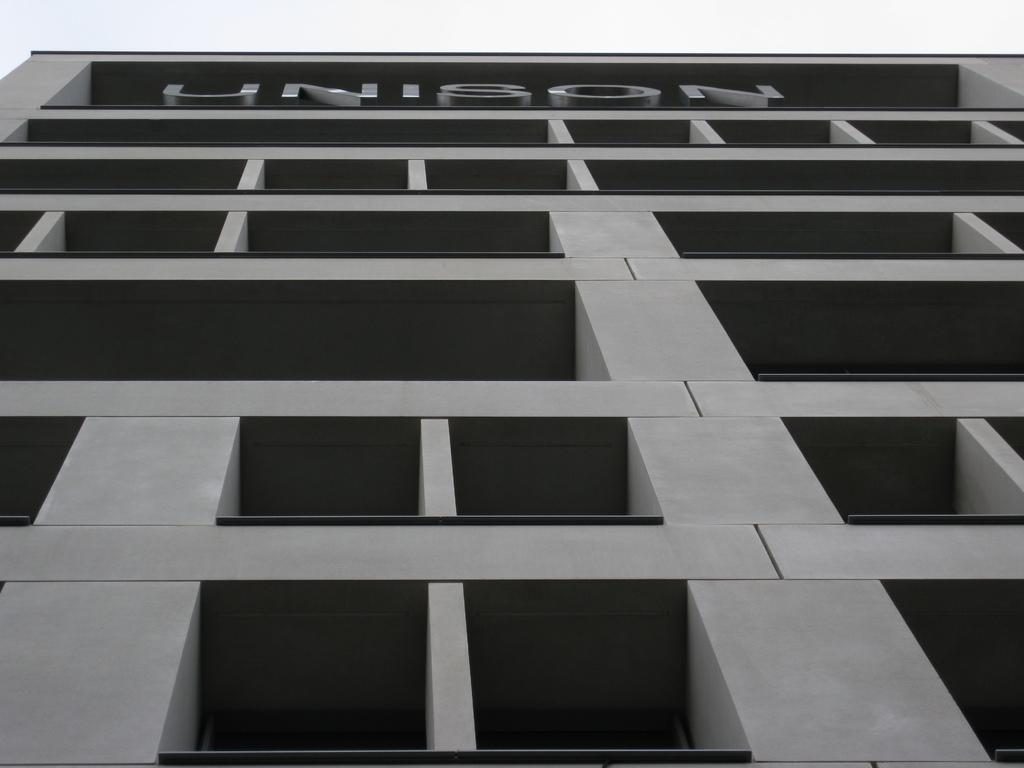What type of structure is visible in the image? There is a building in the image. Can you read the name of the building? The building has a name on it. How many chickens are present in the image? There are no chickens present in the image; it features a building with a name on it. What is the name of the porter in the image? There is no porter present in the image, and therefore no name can be associated with a porter. 